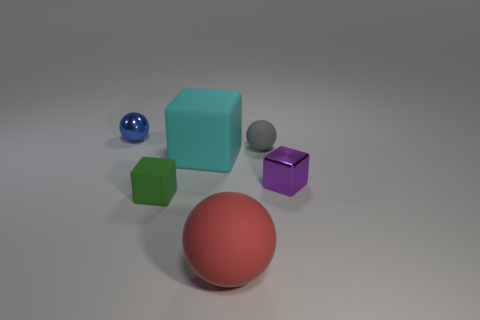Is the number of red balls less than the number of small blocks?
Your answer should be compact. Yes. The tiny sphere that is to the left of the small ball right of the big cyan matte block is made of what material?
Provide a succinct answer. Metal. Is the red sphere the same size as the gray thing?
Your answer should be very brief. No. What number of things are rubber cubes or tiny green things?
Your answer should be compact. 2. How big is the ball that is both behind the purple shiny block and to the right of the small blue thing?
Make the answer very short. Small. Is the number of red spheres that are left of the big red matte thing less than the number of large brown metallic spheres?
Give a very brief answer. No. The big cyan object that is the same material as the tiny green object is what shape?
Provide a succinct answer. Cube. There is a large object behind the small purple shiny object; does it have the same shape as the metallic thing that is right of the green matte cube?
Give a very brief answer. Yes. Is the number of big things in front of the small rubber cube less than the number of blocks on the left side of the large cyan object?
Offer a terse response. No. What number of green cubes have the same size as the red rubber sphere?
Give a very brief answer. 0. 